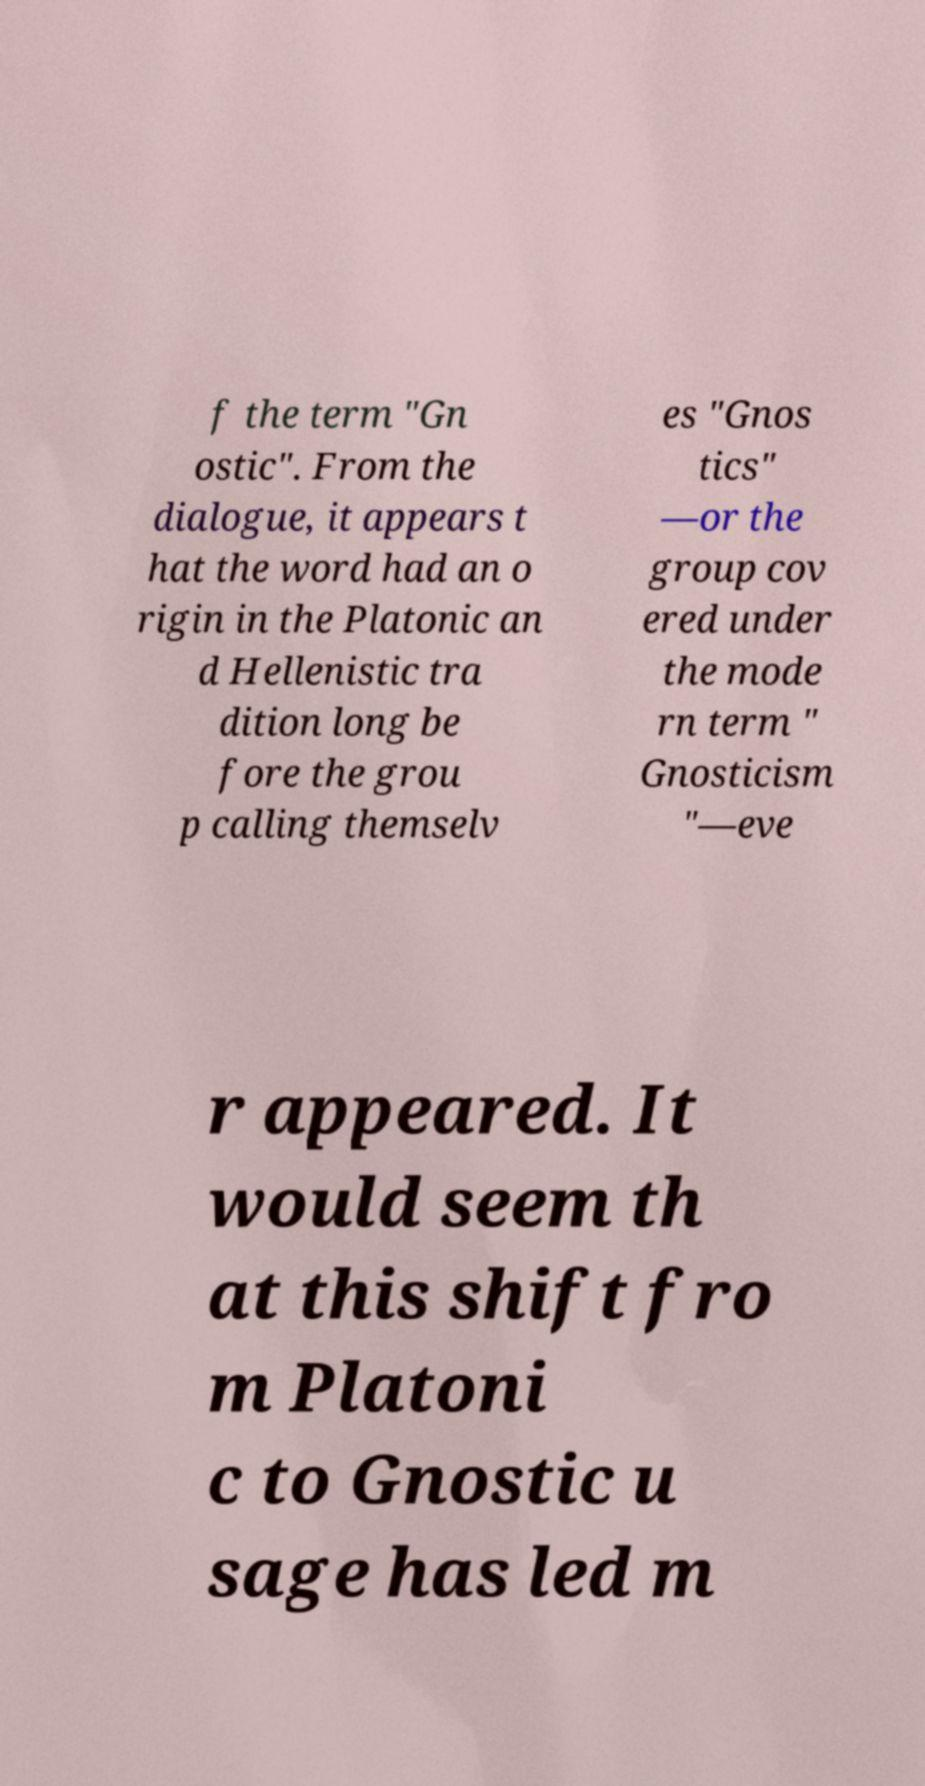I need the written content from this picture converted into text. Can you do that? f the term "Gn ostic". From the dialogue, it appears t hat the word had an o rigin in the Platonic an d Hellenistic tra dition long be fore the grou p calling themselv es "Gnos tics" —or the group cov ered under the mode rn term " Gnosticism "—eve r appeared. It would seem th at this shift fro m Platoni c to Gnostic u sage has led m 